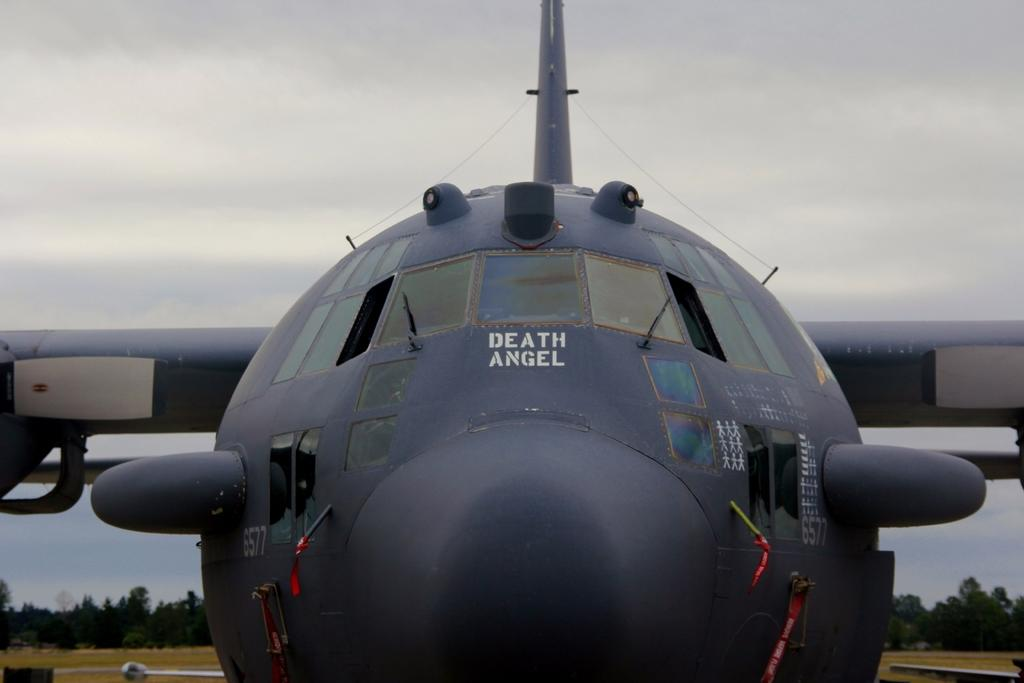Provide a one-sentence caption for the provided image. An up close, face forward picture of the plane the Death Angel. 